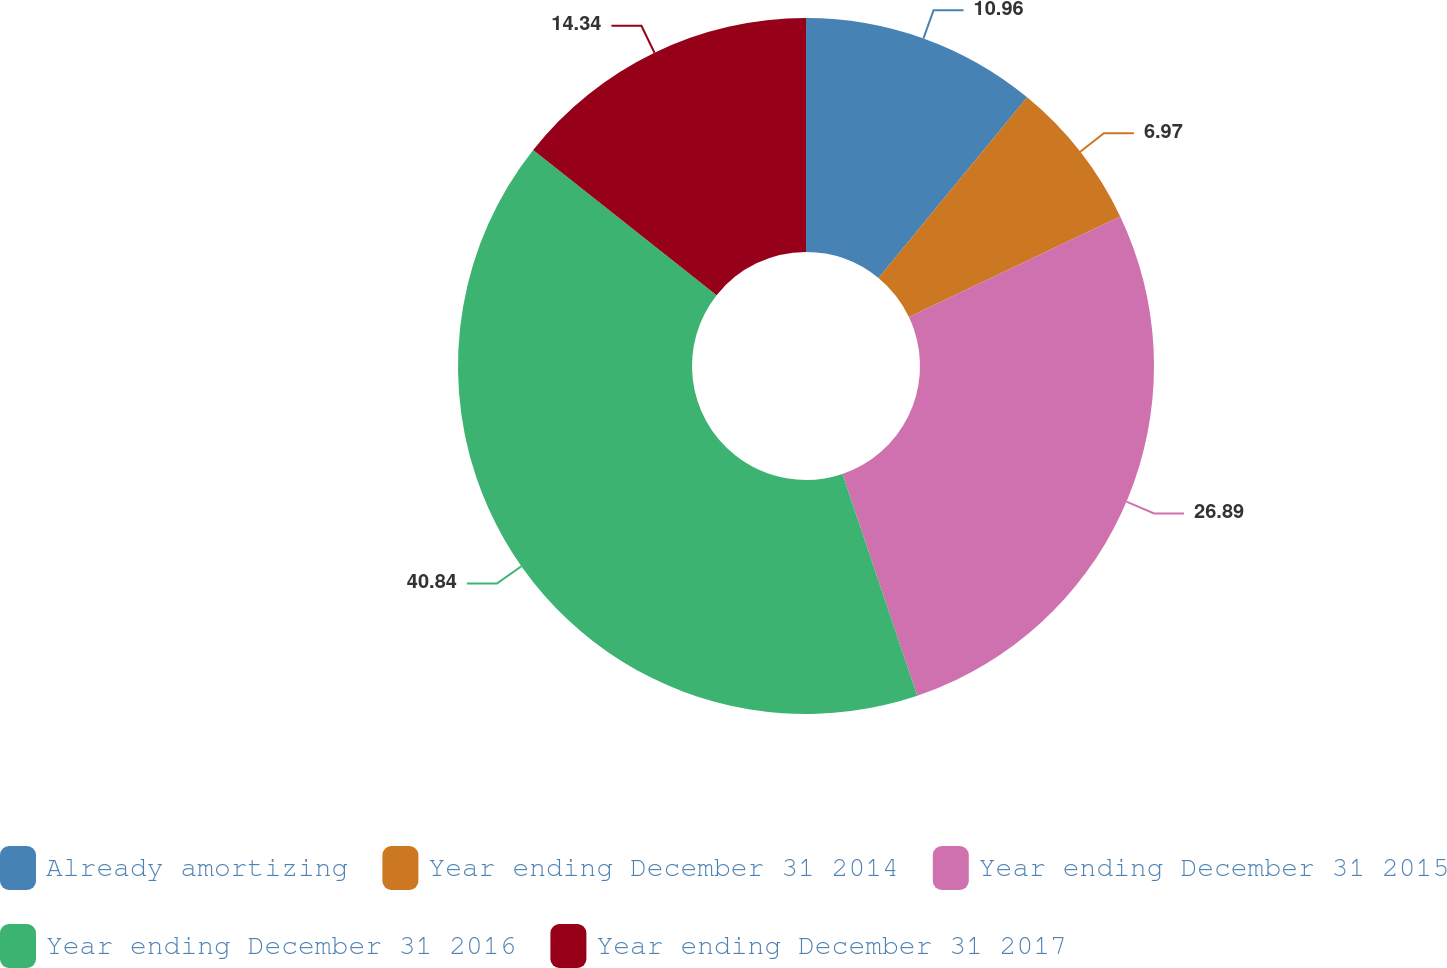<chart> <loc_0><loc_0><loc_500><loc_500><pie_chart><fcel>Already amortizing<fcel>Year ending December 31 2014<fcel>Year ending December 31 2015<fcel>Year ending December 31 2016<fcel>Year ending December 31 2017<nl><fcel>10.96%<fcel>6.97%<fcel>26.89%<fcel>40.84%<fcel>14.34%<nl></chart> 